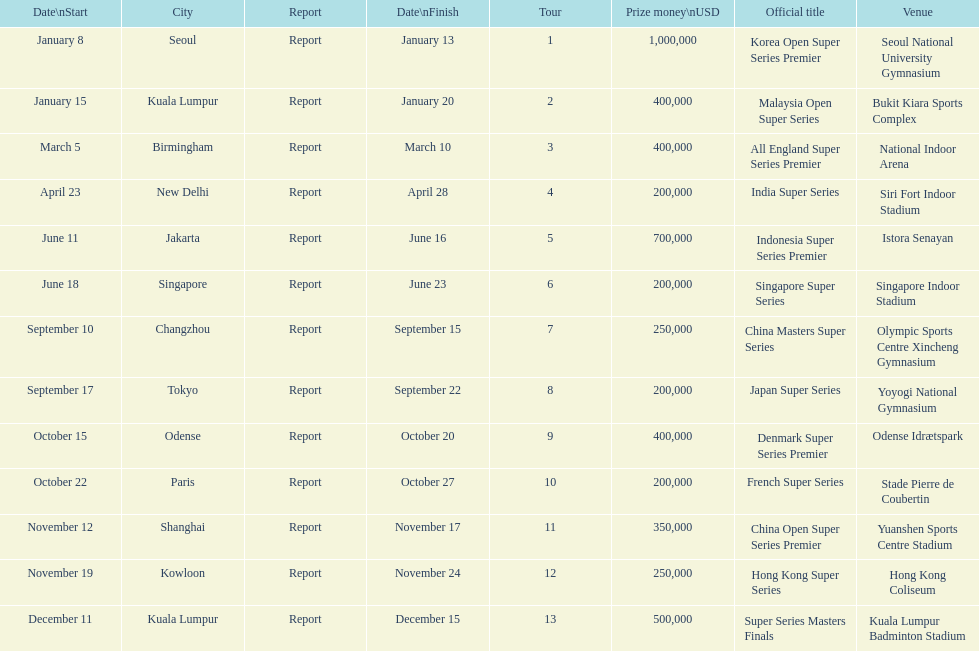What is the total prize payout for all 13 series? 5050000. 